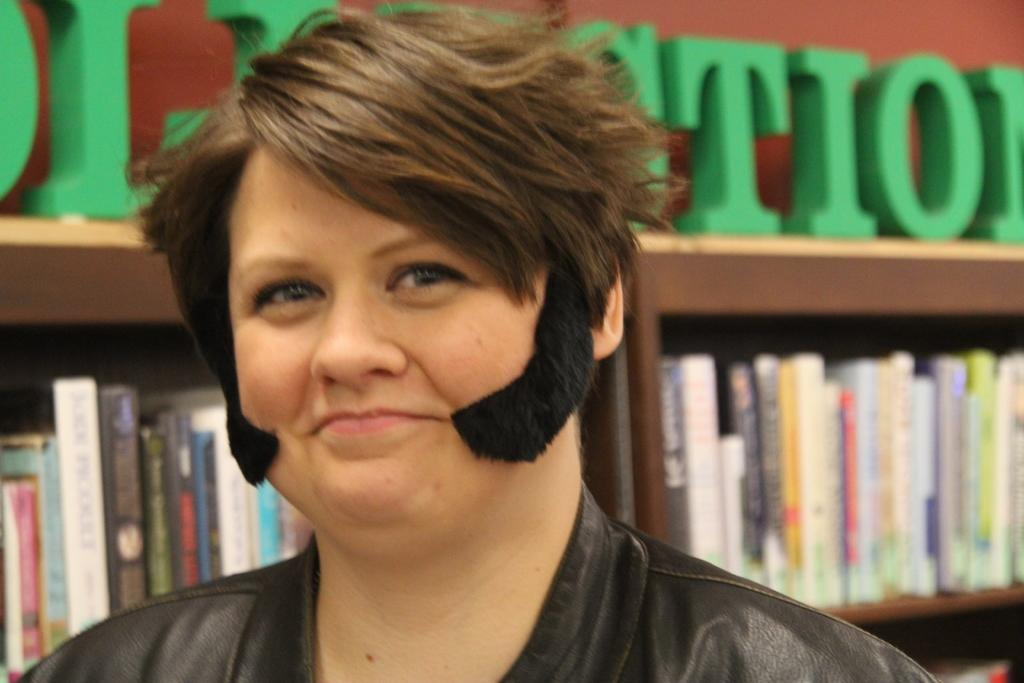Who or what is present in the image? There is a person in the image. What can be seen on the shelves in the image? The shelves have objects, including books. Can you describe the text visible in the background of the image? Unfortunately, the provided facts do not give any information about the text visible in the background. What type of peace is being promoted by the person in the image? There is no indication in the image that the person is promoting any type of peace. 